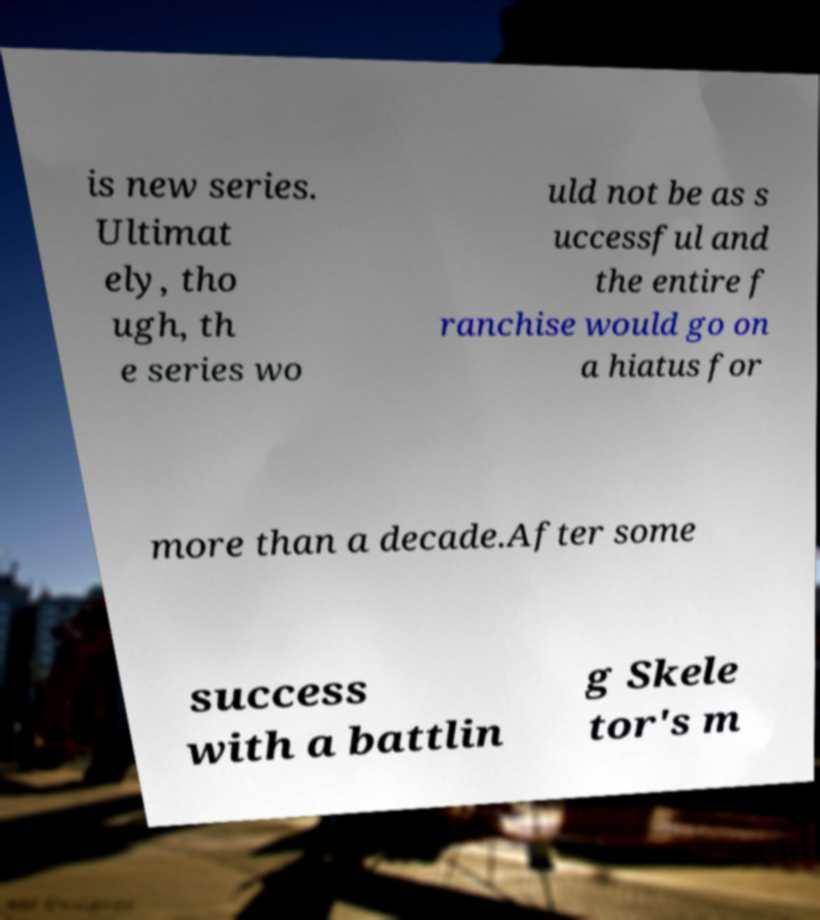What messages or text are displayed in this image? I need them in a readable, typed format. is new series. Ultimat ely, tho ugh, th e series wo uld not be as s uccessful and the entire f ranchise would go on a hiatus for more than a decade.After some success with a battlin g Skele tor's m 